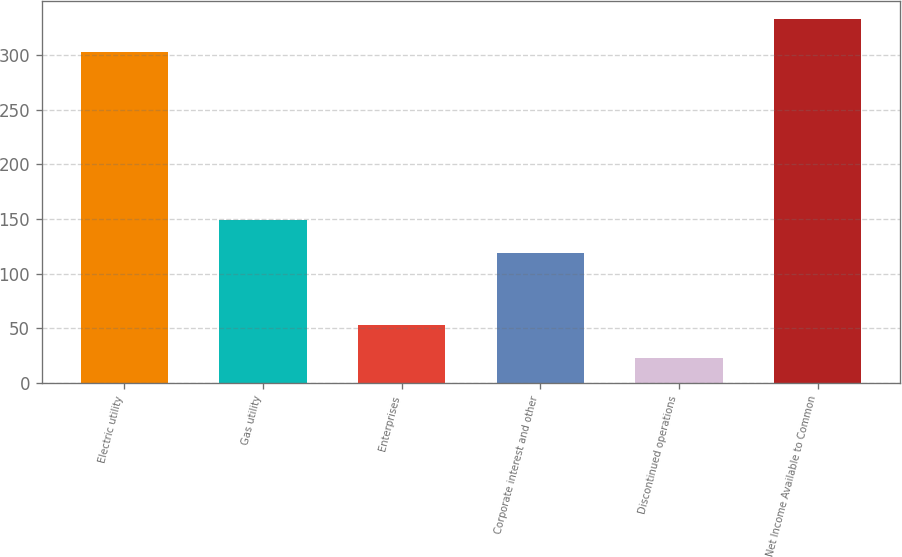<chart> <loc_0><loc_0><loc_500><loc_500><bar_chart><fcel>Electric utility<fcel>Gas utility<fcel>Enterprises<fcel>Corporate interest and other<fcel>Discontinued operations<fcel>Net Income Available to Common<nl><fcel>303<fcel>149.1<fcel>53.1<fcel>119<fcel>23<fcel>333.1<nl></chart> 